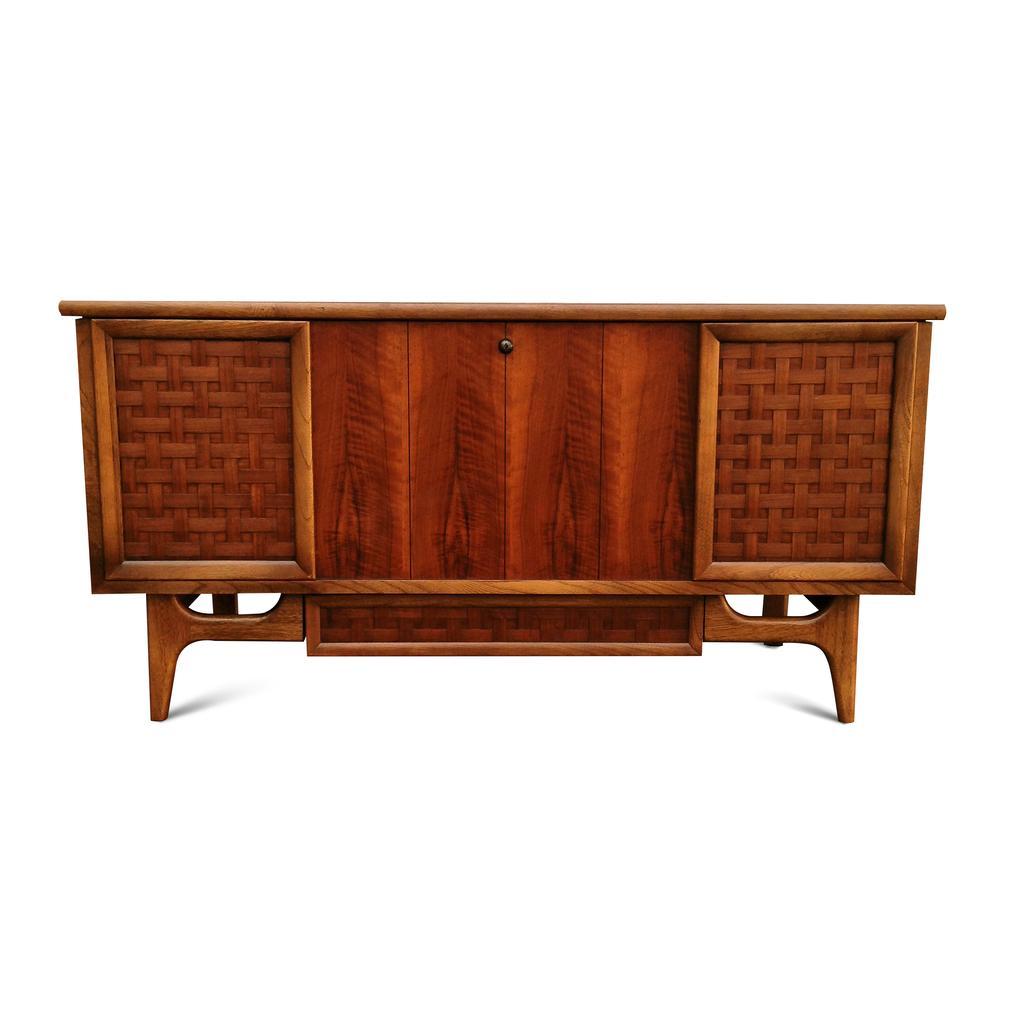Could you give a brief overview of what you see in this image? In the center of the image we can see a table. 